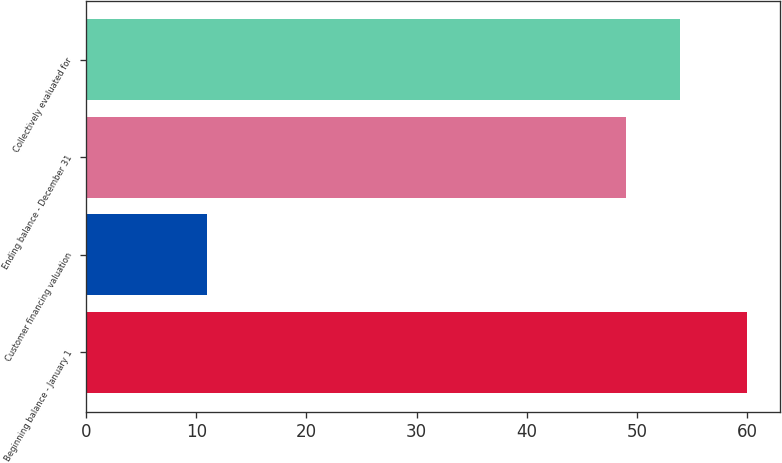<chart> <loc_0><loc_0><loc_500><loc_500><bar_chart><fcel>Beginning balance - January 1<fcel>Customer financing valuation<fcel>Ending balance - December 31<fcel>Collectively evaluated for<nl><fcel>60<fcel>11<fcel>49<fcel>53.9<nl></chart> 